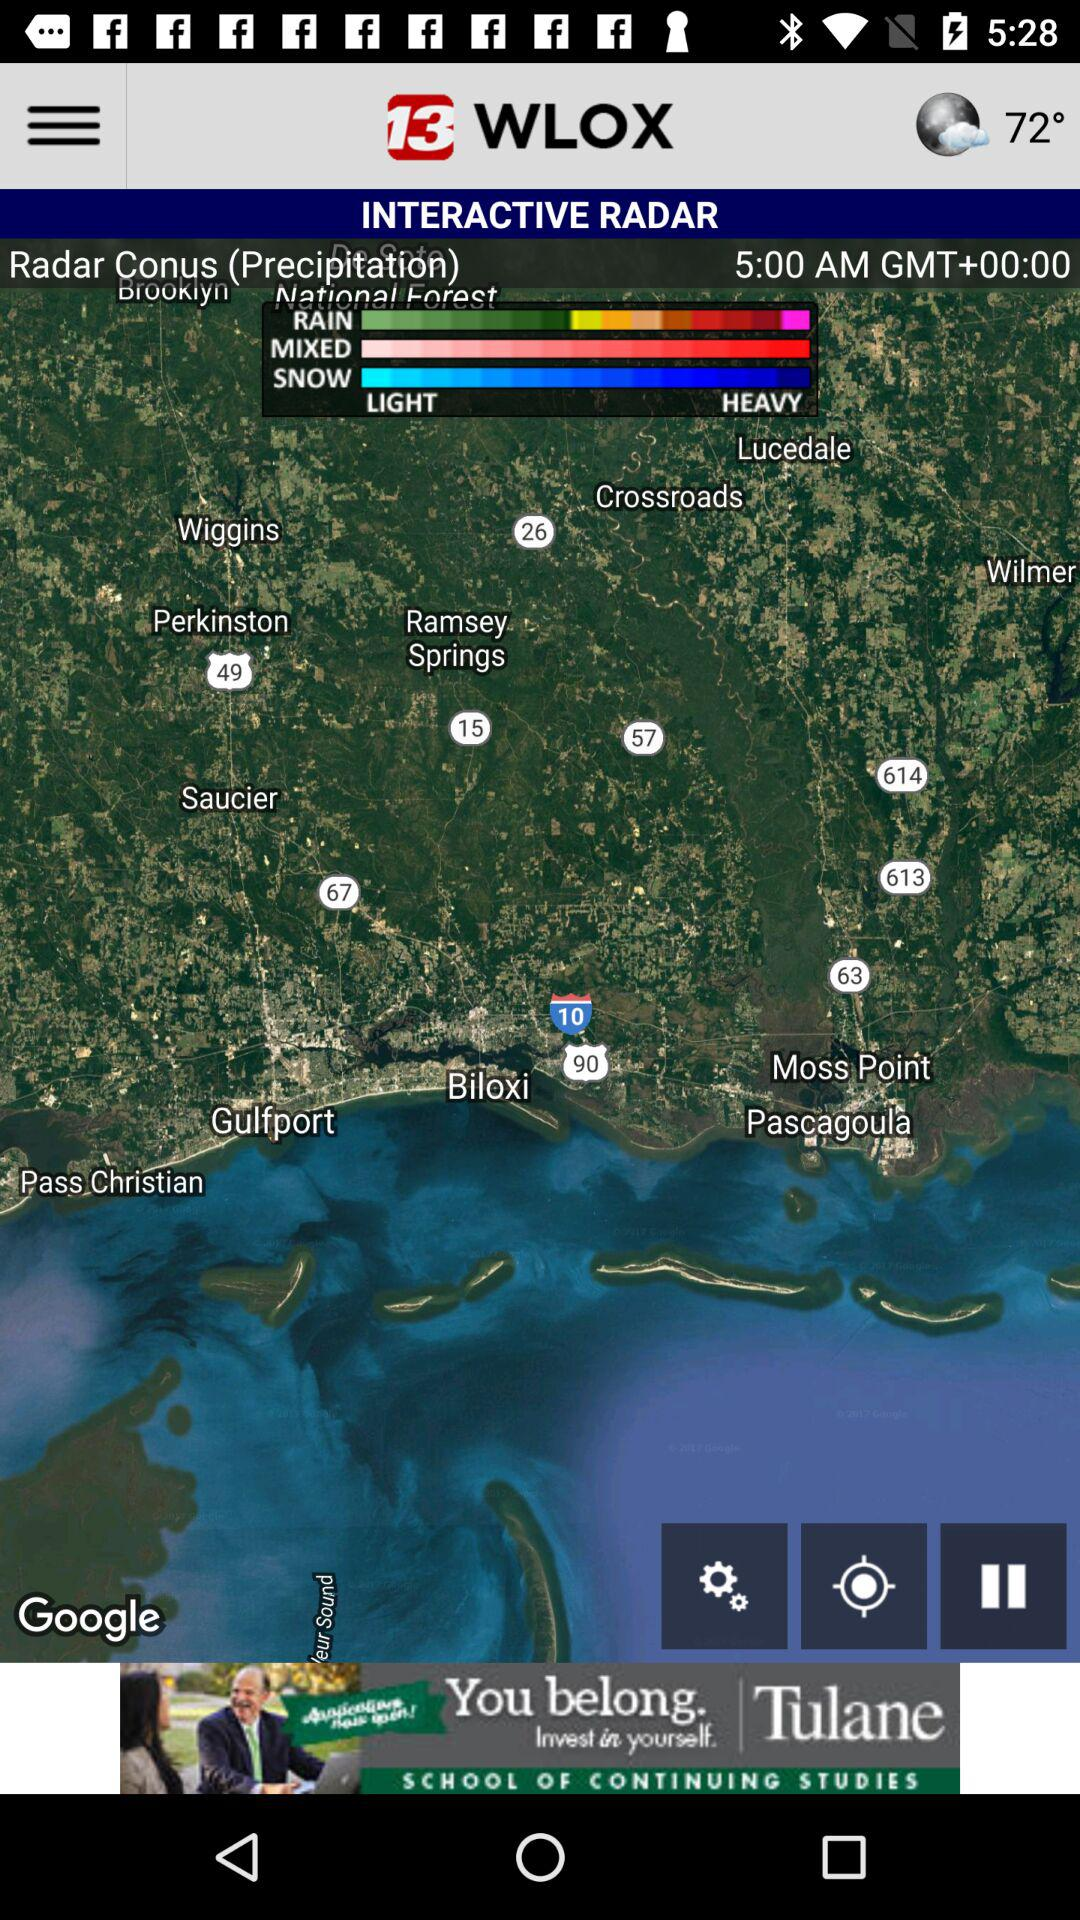What is the given temperature? The given temperature is 72°. 